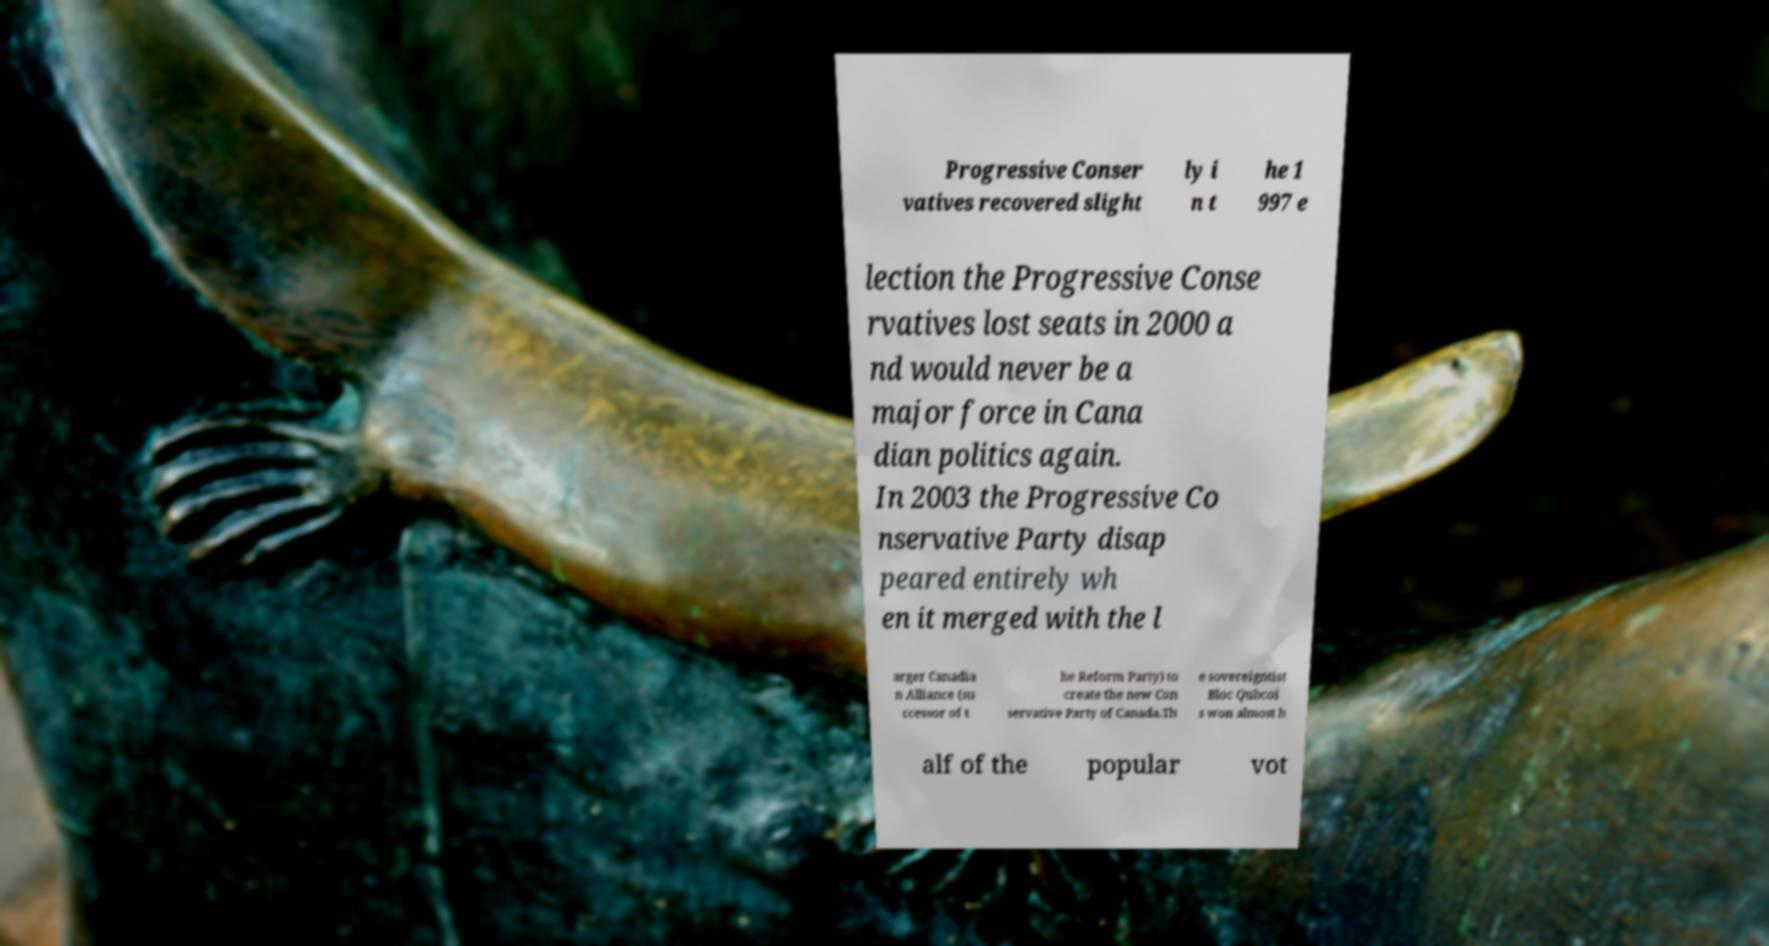Could you assist in decoding the text presented in this image and type it out clearly? Progressive Conser vatives recovered slight ly i n t he 1 997 e lection the Progressive Conse rvatives lost seats in 2000 a nd would never be a major force in Cana dian politics again. In 2003 the Progressive Co nservative Party disap peared entirely wh en it merged with the l arger Canadia n Alliance (su ccessor of t he Reform Party) to create the new Con servative Party of Canada.Th e sovereigntist Bloc Qubcoi s won almost h alf of the popular vot 